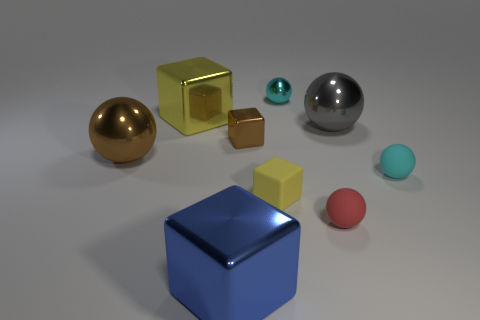Subtract all big gray metallic spheres. How many spheres are left? 4 Subtract all brown balls. How many balls are left? 4 Subtract all red balls. Subtract all green cylinders. How many balls are left? 4 Subtract all spheres. How many objects are left? 4 Subtract 0 yellow cylinders. How many objects are left? 9 Subtract all big brown metal spheres. Subtract all big blue metallic things. How many objects are left? 7 Add 3 metallic cubes. How many metallic cubes are left? 6 Add 8 small shiny things. How many small shiny things exist? 10 